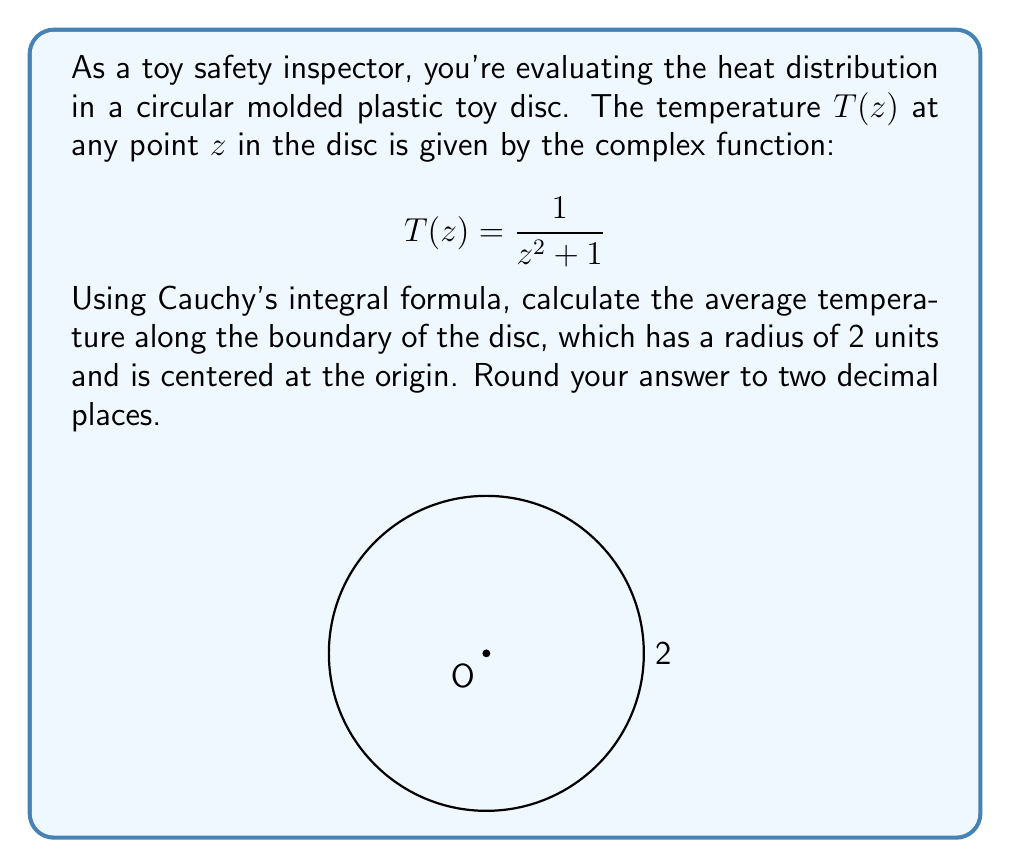Help me with this question. Let's approach this step-by-step using Cauchy's integral formula:

1) Cauchy's integral formula states that for an analytic function $f(z)$ inside and on a simple closed contour $C$:

   $$f(a) = \frac{1}{2\pi i} \oint_C \frac{f(z)}{z-a} dz$$

2) In our case, $f(z) = T(z) = \frac{1}{z^2 + 1}$, and we want the average value on the circle $|z| = 2$. This is equivalent to finding $f(0)$:

   $$f(0) = \frac{1}{2\pi i} \oint_{|z|=2} \frac{f(z)}{z-0} dz = \frac{1}{2\pi i} \oint_{|z|=2} \frac{1}{z(z^2 + 1)} dz$$

3) To evaluate this, we can use the residue theorem. The integrand has poles at $z = 0$, $z = i$, and $z = -i$. Only $z = 0$ is inside our contour.

4) The residue at $z = 0$ is:

   $$\text{Res}(f,0) = \lim_{z \to 0} z \cdot \frac{1}{z(z^2 + 1)} = \lim_{z \to 0} \frac{1}{z^2 + 1} = 1$$

5) By the residue theorem:

   $$f(0) = 2\pi i \cdot \text{Res}(f,0) = 2\pi i \cdot 1 = 2\pi i$$

6) The average temperature is the real part of this value:

   $$\text{Average Temperature} = \text{Re}(2\pi i) = 0$$

7) Rounding to two decimal places gives 0.00.
Answer: 0.00 